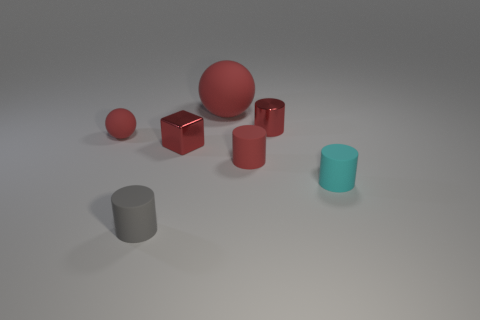Subtract all blue cylinders. Subtract all purple balls. How many cylinders are left? 4 Add 1 big red spheres. How many objects exist? 8 Subtract all cylinders. How many objects are left? 3 Subtract all cyan things. Subtract all cyan spheres. How many objects are left? 6 Add 2 big red balls. How many big red balls are left? 3 Add 5 cylinders. How many cylinders exist? 9 Subtract 0 purple blocks. How many objects are left? 7 